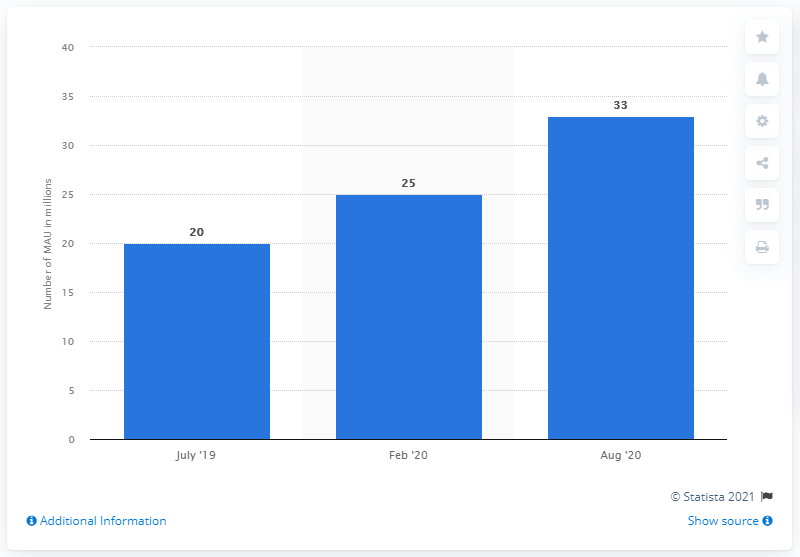Highlight a few significant elements in this photo. The median is the middle value in a set of data when the data is arranged in order, while the least value is the lowest value in the set. We do not have the information on the number of monthly active users in February 2020. Tubi has 33 monthly active users. 